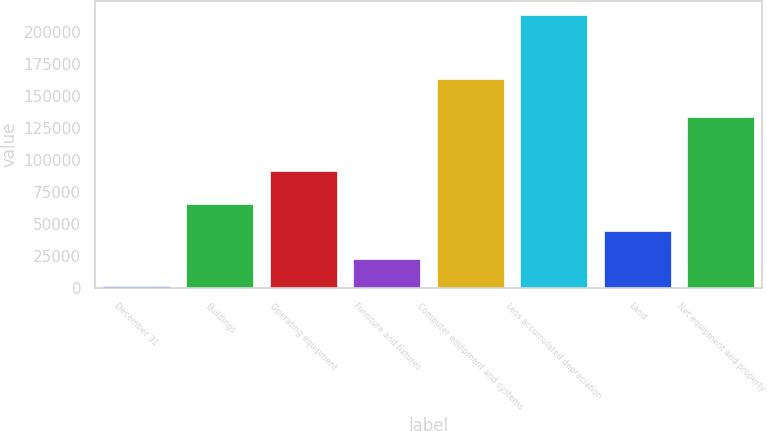Convert chart. <chart><loc_0><loc_0><loc_500><loc_500><bar_chart><fcel>December 31<fcel>Buildings<fcel>Operating equipment<fcel>Furniture and fixtures<fcel>Computer equipment and systems<fcel>Less accumulated depreciation<fcel>Land<fcel>Net equipment and property<nl><fcel>2017<fcel>65554.6<fcel>91430<fcel>23196.2<fcel>163220<fcel>213809<fcel>44375.4<fcel>134088<nl></chart> 